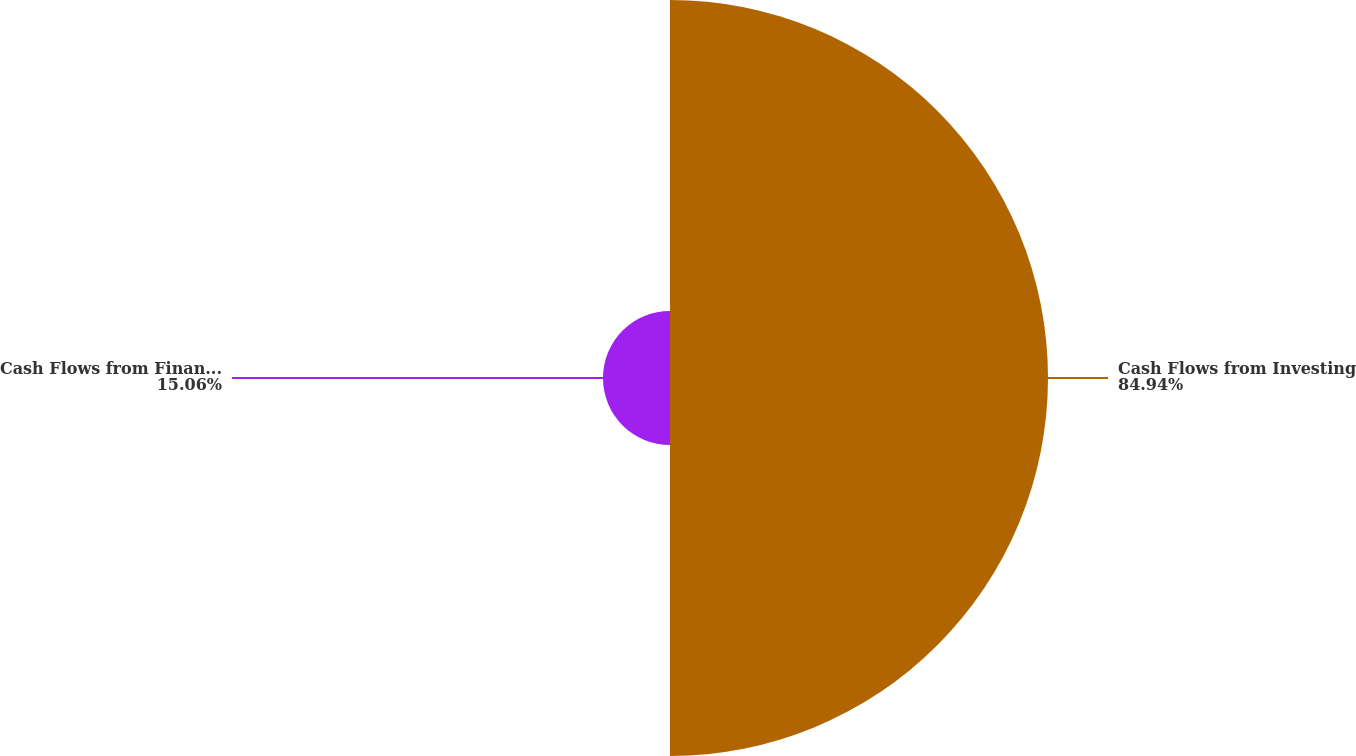Convert chart. <chart><loc_0><loc_0><loc_500><loc_500><pie_chart><fcel>Cash Flows from Investing<fcel>Cash Flows from Financing<nl><fcel>84.94%<fcel>15.06%<nl></chart> 